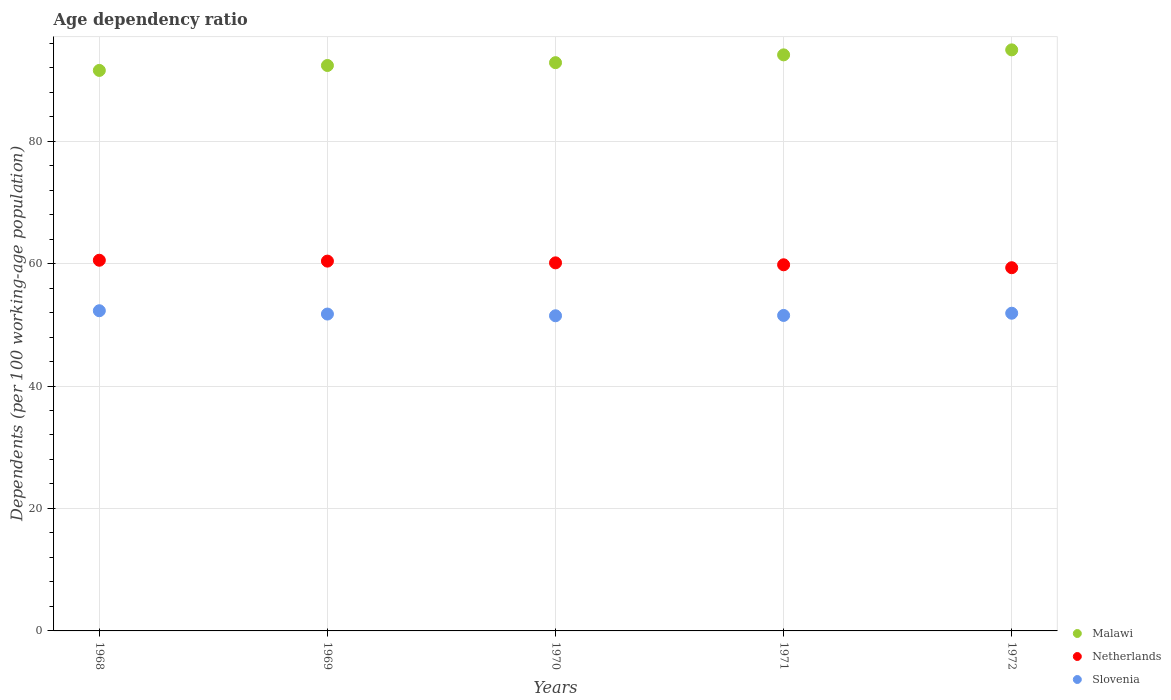What is the age dependency ratio in in Slovenia in 1972?
Offer a terse response. 51.89. Across all years, what is the maximum age dependency ratio in in Slovenia?
Provide a succinct answer. 52.3. Across all years, what is the minimum age dependency ratio in in Malawi?
Ensure brevity in your answer.  91.55. In which year was the age dependency ratio in in Slovenia maximum?
Ensure brevity in your answer.  1968. In which year was the age dependency ratio in in Slovenia minimum?
Keep it short and to the point. 1970. What is the total age dependency ratio in in Slovenia in the graph?
Your response must be concise. 258.94. What is the difference between the age dependency ratio in in Malawi in 1969 and that in 1970?
Ensure brevity in your answer.  -0.46. What is the difference between the age dependency ratio in in Malawi in 1968 and the age dependency ratio in in Slovenia in 1970?
Your answer should be compact. 40.07. What is the average age dependency ratio in in Netherlands per year?
Your answer should be very brief. 60.04. In the year 1969, what is the difference between the age dependency ratio in in Slovenia and age dependency ratio in in Netherlands?
Give a very brief answer. -8.65. What is the ratio of the age dependency ratio in in Malawi in 1969 to that in 1971?
Your answer should be very brief. 0.98. Is the difference between the age dependency ratio in in Slovenia in 1968 and 1971 greater than the difference between the age dependency ratio in in Netherlands in 1968 and 1971?
Offer a very short reply. Yes. What is the difference between the highest and the second highest age dependency ratio in in Malawi?
Your answer should be very brief. 0.82. What is the difference between the highest and the lowest age dependency ratio in in Netherlands?
Give a very brief answer. 1.22. In how many years, is the age dependency ratio in in Netherlands greater than the average age dependency ratio in in Netherlands taken over all years?
Your answer should be very brief. 3. Is the sum of the age dependency ratio in in Netherlands in 1970 and 1972 greater than the maximum age dependency ratio in in Slovenia across all years?
Offer a terse response. Yes. Is the age dependency ratio in in Netherlands strictly greater than the age dependency ratio in in Slovenia over the years?
Your answer should be compact. Yes. Is the age dependency ratio in in Netherlands strictly less than the age dependency ratio in in Malawi over the years?
Your response must be concise. Yes. How many dotlines are there?
Offer a very short reply. 3. How many years are there in the graph?
Your response must be concise. 5. Does the graph contain any zero values?
Your answer should be very brief. No. Where does the legend appear in the graph?
Keep it short and to the point. Bottom right. How are the legend labels stacked?
Provide a short and direct response. Vertical. What is the title of the graph?
Keep it short and to the point. Age dependency ratio. What is the label or title of the Y-axis?
Offer a terse response. Dependents (per 100 working-age population). What is the Dependents (per 100 working-age population) in Malawi in 1968?
Give a very brief answer. 91.55. What is the Dependents (per 100 working-age population) in Netherlands in 1968?
Your answer should be very brief. 60.54. What is the Dependents (per 100 working-age population) in Slovenia in 1968?
Your answer should be compact. 52.3. What is the Dependents (per 100 working-age population) of Malawi in 1969?
Ensure brevity in your answer.  92.35. What is the Dependents (per 100 working-age population) of Netherlands in 1969?
Your answer should be compact. 60.4. What is the Dependents (per 100 working-age population) of Slovenia in 1969?
Your answer should be very brief. 51.75. What is the Dependents (per 100 working-age population) of Malawi in 1970?
Offer a very short reply. 92.81. What is the Dependents (per 100 working-age population) of Netherlands in 1970?
Give a very brief answer. 60.12. What is the Dependents (per 100 working-age population) of Slovenia in 1970?
Give a very brief answer. 51.47. What is the Dependents (per 100 working-age population) in Malawi in 1971?
Ensure brevity in your answer.  94.09. What is the Dependents (per 100 working-age population) in Netherlands in 1971?
Provide a short and direct response. 59.8. What is the Dependents (per 100 working-age population) of Slovenia in 1971?
Make the answer very short. 51.53. What is the Dependents (per 100 working-age population) in Malawi in 1972?
Keep it short and to the point. 94.9. What is the Dependents (per 100 working-age population) in Netherlands in 1972?
Ensure brevity in your answer.  59.32. What is the Dependents (per 100 working-age population) in Slovenia in 1972?
Give a very brief answer. 51.89. Across all years, what is the maximum Dependents (per 100 working-age population) of Malawi?
Give a very brief answer. 94.9. Across all years, what is the maximum Dependents (per 100 working-age population) of Netherlands?
Make the answer very short. 60.54. Across all years, what is the maximum Dependents (per 100 working-age population) of Slovenia?
Your answer should be compact. 52.3. Across all years, what is the minimum Dependents (per 100 working-age population) of Malawi?
Make the answer very short. 91.55. Across all years, what is the minimum Dependents (per 100 working-age population) of Netherlands?
Your answer should be compact. 59.32. Across all years, what is the minimum Dependents (per 100 working-age population) in Slovenia?
Your answer should be compact. 51.47. What is the total Dependents (per 100 working-age population) of Malawi in the graph?
Make the answer very short. 465.7. What is the total Dependents (per 100 working-age population) in Netherlands in the graph?
Ensure brevity in your answer.  300.18. What is the total Dependents (per 100 working-age population) in Slovenia in the graph?
Your answer should be compact. 258.94. What is the difference between the Dependents (per 100 working-age population) of Malawi in 1968 and that in 1969?
Ensure brevity in your answer.  -0.8. What is the difference between the Dependents (per 100 working-age population) in Netherlands in 1968 and that in 1969?
Offer a terse response. 0.14. What is the difference between the Dependents (per 100 working-age population) of Slovenia in 1968 and that in 1969?
Give a very brief answer. 0.54. What is the difference between the Dependents (per 100 working-age population) in Malawi in 1968 and that in 1970?
Your response must be concise. -1.27. What is the difference between the Dependents (per 100 working-age population) in Netherlands in 1968 and that in 1970?
Your answer should be compact. 0.43. What is the difference between the Dependents (per 100 working-age population) in Slovenia in 1968 and that in 1970?
Give a very brief answer. 0.82. What is the difference between the Dependents (per 100 working-age population) of Malawi in 1968 and that in 1971?
Provide a short and direct response. -2.54. What is the difference between the Dependents (per 100 working-age population) of Netherlands in 1968 and that in 1971?
Your answer should be compact. 0.74. What is the difference between the Dependents (per 100 working-age population) in Slovenia in 1968 and that in 1971?
Your answer should be very brief. 0.77. What is the difference between the Dependents (per 100 working-age population) in Malawi in 1968 and that in 1972?
Your answer should be compact. -3.36. What is the difference between the Dependents (per 100 working-age population) in Netherlands in 1968 and that in 1972?
Offer a very short reply. 1.22. What is the difference between the Dependents (per 100 working-age population) in Slovenia in 1968 and that in 1972?
Offer a very short reply. 0.41. What is the difference between the Dependents (per 100 working-age population) in Malawi in 1969 and that in 1970?
Give a very brief answer. -0.46. What is the difference between the Dependents (per 100 working-age population) in Netherlands in 1969 and that in 1970?
Offer a very short reply. 0.28. What is the difference between the Dependents (per 100 working-age population) of Slovenia in 1969 and that in 1970?
Make the answer very short. 0.28. What is the difference between the Dependents (per 100 working-age population) in Malawi in 1969 and that in 1971?
Make the answer very short. -1.74. What is the difference between the Dependents (per 100 working-age population) of Netherlands in 1969 and that in 1971?
Keep it short and to the point. 0.6. What is the difference between the Dependents (per 100 working-age population) in Slovenia in 1969 and that in 1971?
Provide a short and direct response. 0.23. What is the difference between the Dependents (per 100 working-age population) of Malawi in 1969 and that in 1972?
Offer a terse response. -2.55. What is the difference between the Dependents (per 100 working-age population) in Netherlands in 1969 and that in 1972?
Provide a short and direct response. 1.08. What is the difference between the Dependents (per 100 working-age population) of Slovenia in 1969 and that in 1972?
Your response must be concise. -0.13. What is the difference between the Dependents (per 100 working-age population) in Malawi in 1970 and that in 1971?
Your answer should be very brief. -1.27. What is the difference between the Dependents (per 100 working-age population) of Netherlands in 1970 and that in 1971?
Your answer should be compact. 0.32. What is the difference between the Dependents (per 100 working-age population) of Slovenia in 1970 and that in 1971?
Your answer should be compact. -0.05. What is the difference between the Dependents (per 100 working-age population) of Malawi in 1970 and that in 1972?
Offer a terse response. -2.09. What is the difference between the Dependents (per 100 working-age population) of Netherlands in 1970 and that in 1972?
Give a very brief answer. 0.79. What is the difference between the Dependents (per 100 working-age population) of Slovenia in 1970 and that in 1972?
Your response must be concise. -0.41. What is the difference between the Dependents (per 100 working-age population) in Malawi in 1971 and that in 1972?
Provide a short and direct response. -0.82. What is the difference between the Dependents (per 100 working-age population) of Netherlands in 1971 and that in 1972?
Your answer should be very brief. 0.48. What is the difference between the Dependents (per 100 working-age population) of Slovenia in 1971 and that in 1972?
Provide a short and direct response. -0.36. What is the difference between the Dependents (per 100 working-age population) in Malawi in 1968 and the Dependents (per 100 working-age population) in Netherlands in 1969?
Give a very brief answer. 31.15. What is the difference between the Dependents (per 100 working-age population) of Malawi in 1968 and the Dependents (per 100 working-age population) of Slovenia in 1969?
Your response must be concise. 39.79. What is the difference between the Dependents (per 100 working-age population) of Netherlands in 1968 and the Dependents (per 100 working-age population) of Slovenia in 1969?
Make the answer very short. 8.79. What is the difference between the Dependents (per 100 working-age population) of Malawi in 1968 and the Dependents (per 100 working-age population) of Netherlands in 1970?
Your response must be concise. 31.43. What is the difference between the Dependents (per 100 working-age population) in Malawi in 1968 and the Dependents (per 100 working-age population) in Slovenia in 1970?
Keep it short and to the point. 40.07. What is the difference between the Dependents (per 100 working-age population) in Netherlands in 1968 and the Dependents (per 100 working-age population) in Slovenia in 1970?
Your answer should be compact. 9.07. What is the difference between the Dependents (per 100 working-age population) of Malawi in 1968 and the Dependents (per 100 working-age population) of Netherlands in 1971?
Provide a succinct answer. 31.75. What is the difference between the Dependents (per 100 working-age population) of Malawi in 1968 and the Dependents (per 100 working-age population) of Slovenia in 1971?
Give a very brief answer. 40.02. What is the difference between the Dependents (per 100 working-age population) in Netherlands in 1968 and the Dependents (per 100 working-age population) in Slovenia in 1971?
Provide a short and direct response. 9.01. What is the difference between the Dependents (per 100 working-age population) in Malawi in 1968 and the Dependents (per 100 working-age population) in Netherlands in 1972?
Provide a succinct answer. 32.22. What is the difference between the Dependents (per 100 working-age population) of Malawi in 1968 and the Dependents (per 100 working-age population) of Slovenia in 1972?
Your answer should be compact. 39.66. What is the difference between the Dependents (per 100 working-age population) in Netherlands in 1968 and the Dependents (per 100 working-age population) in Slovenia in 1972?
Provide a succinct answer. 8.65. What is the difference between the Dependents (per 100 working-age population) in Malawi in 1969 and the Dependents (per 100 working-age population) in Netherlands in 1970?
Ensure brevity in your answer.  32.24. What is the difference between the Dependents (per 100 working-age population) of Malawi in 1969 and the Dependents (per 100 working-age population) of Slovenia in 1970?
Make the answer very short. 40.88. What is the difference between the Dependents (per 100 working-age population) of Netherlands in 1969 and the Dependents (per 100 working-age population) of Slovenia in 1970?
Keep it short and to the point. 8.93. What is the difference between the Dependents (per 100 working-age population) in Malawi in 1969 and the Dependents (per 100 working-age population) in Netherlands in 1971?
Your answer should be very brief. 32.55. What is the difference between the Dependents (per 100 working-age population) of Malawi in 1969 and the Dependents (per 100 working-age population) of Slovenia in 1971?
Your answer should be compact. 40.82. What is the difference between the Dependents (per 100 working-age population) of Netherlands in 1969 and the Dependents (per 100 working-age population) of Slovenia in 1971?
Make the answer very short. 8.87. What is the difference between the Dependents (per 100 working-age population) in Malawi in 1969 and the Dependents (per 100 working-age population) in Netherlands in 1972?
Your answer should be very brief. 33.03. What is the difference between the Dependents (per 100 working-age population) of Malawi in 1969 and the Dependents (per 100 working-age population) of Slovenia in 1972?
Your answer should be very brief. 40.46. What is the difference between the Dependents (per 100 working-age population) of Netherlands in 1969 and the Dependents (per 100 working-age population) of Slovenia in 1972?
Your answer should be very brief. 8.51. What is the difference between the Dependents (per 100 working-age population) in Malawi in 1970 and the Dependents (per 100 working-age population) in Netherlands in 1971?
Make the answer very short. 33.01. What is the difference between the Dependents (per 100 working-age population) in Malawi in 1970 and the Dependents (per 100 working-age population) in Slovenia in 1971?
Your response must be concise. 41.28. What is the difference between the Dependents (per 100 working-age population) in Netherlands in 1970 and the Dependents (per 100 working-age population) in Slovenia in 1971?
Offer a terse response. 8.59. What is the difference between the Dependents (per 100 working-age population) in Malawi in 1970 and the Dependents (per 100 working-age population) in Netherlands in 1972?
Ensure brevity in your answer.  33.49. What is the difference between the Dependents (per 100 working-age population) of Malawi in 1970 and the Dependents (per 100 working-age population) of Slovenia in 1972?
Ensure brevity in your answer.  40.92. What is the difference between the Dependents (per 100 working-age population) of Netherlands in 1970 and the Dependents (per 100 working-age population) of Slovenia in 1972?
Make the answer very short. 8.23. What is the difference between the Dependents (per 100 working-age population) in Malawi in 1971 and the Dependents (per 100 working-age population) in Netherlands in 1972?
Offer a terse response. 34.77. What is the difference between the Dependents (per 100 working-age population) of Malawi in 1971 and the Dependents (per 100 working-age population) of Slovenia in 1972?
Give a very brief answer. 42.2. What is the difference between the Dependents (per 100 working-age population) in Netherlands in 1971 and the Dependents (per 100 working-age population) in Slovenia in 1972?
Your answer should be very brief. 7.91. What is the average Dependents (per 100 working-age population) in Malawi per year?
Provide a succinct answer. 93.14. What is the average Dependents (per 100 working-age population) in Netherlands per year?
Your response must be concise. 60.04. What is the average Dependents (per 100 working-age population) of Slovenia per year?
Keep it short and to the point. 51.79. In the year 1968, what is the difference between the Dependents (per 100 working-age population) of Malawi and Dependents (per 100 working-age population) of Netherlands?
Your answer should be very brief. 31. In the year 1968, what is the difference between the Dependents (per 100 working-age population) in Malawi and Dependents (per 100 working-age population) in Slovenia?
Keep it short and to the point. 39.25. In the year 1968, what is the difference between the Dependents (per 100 working-age population) of Netherlands and Dependents (per 100 working-age population) of Slovenia?
Your response must be concise. 8.25. In the year 1969, what is the difference between the Dependents (per 100 working-age population) in Malawi and Dependents (per 100 working-age population) in Netherlands?
Give a very brief answer. 31.95. In the year 1969, what is the difference between the Dependents (per 100 working-age population) in Malawi and Dependents (per 100 working-age population) in Slovenia?
Your answer should be very brief. 40.6. In the year 1969, what is the difference between the Dependents (per 100 working-age population) in Netherlands and Dependents (per 100 working-age population) in Slovenia?
Make the answer very short. 8.65. In the year 1970, what is the difference between the Dependents (per 100 working-age population) in Malawi and Dependents (per 100 working-age population) in Netherlands?
Your answer should be very brief. 32.7. In the year 1970, what is the difference between the Dependents (per 100 working-age population) of Malawi and Dependents (per 100 working-age population) of Slovenia?
Offer a very short reply. 41.34. In the year 1970, what is the difference between the Dependents (per 100 working-age population) in Netherlands and Dependents (per 100 working-age population) in Slovenia?
Offer a very short reply. 8.64. In the year 1971, what is the difference between the Dependents (per 100 working-age population) of Malawi and Dependents (per 100 working-age population) of Netherlands?
Make the answer very short. 34.29. In the year 1971, what is the difference between the Dependents (per 100 working-age population) of Malawi and Dependents (per 100 working-age population) of Slovenia?
Your response must be concise. 42.56. In the year 1971, what is the difference between the Dependents (per 100 working-age population) of Netherlands and Dependents (per 100 working-age population) of Slovenia?
Provide a short and direct response. 8.27. In the year 1972, what is the difference between the Dependents (per 100 working-age population) of Malawi and Dependents (per 100 working-age population) of Netherlands?
Ensure brevity in your answer.  35.58. In the year 1972, what is the difference between the Dependents (per 100 working-age population) of Malawi and Dependents (per 100 working-age population) of Slovenia?
Your answer should be very brief. 43.01. In the year 1972, what is the difference between the Dependents (per 100 working-age population) of Netherlands and Dependents (per 100 working-age population) of Slovenia?
Give a very brief answer. 7.43. What is the ratio of the Dependents (per 100 working-age population) in Slovenia in 1968 to that in 1969?
Ensure brevity in your answer.  1.01. What is the ratio of the Dependents (per 100 working-age population) in Malawi in 1968 to that in 1970?
Provide a succinct answer. 0.99. What is the ratio of the Dependents (per 100 working-age population) of Netherlands in 1968 to that in 1970?
Offer a very short reply. 1.01. What is the ratio of the Dependents (per 100 working-age population) of Slovenia in 1968 to that in 1970?
Offer a terse response. 1.02. What is the ratio of the Dependents (per 100 working-age population) in Malawi in 1968 to that in 1971?
Offer a very short reply. 0.97. What is the ratio of the Dependents (per 100 working-age population) of Netherlands in 1968 to that in 1971?
Offer a very short reply. 1.01. What is the ratio of the Dependents (per 100 working-age population) of Slovenia in 1968 to that in 1971?
Give a very brief answer. 1.01. What is the ratio of the Dependents (per 100 working-age population) in Malawi in 1968 to that in 1972?
Offer a terse response. 0.96. What is the ratio of the Dependents (per 100 working-age population) of Netherlands in 1968 to that in 1972?
Your answer should be very brief. 1.02. What is the ratio of the Dependents (per 100 working-age population) of Netherlands in 1969 to that in 1970?
Keep it short and to the point. 1. What is the ratio of the Dependents (per 100 working-age population) in Slovenia in 1969 to that in 1970?
Provide a succinct answer. 1.01. What is the ratio of the Dependents (per 100 working-age population) in Malawi in 1969 to that in 1971?
Provide a succinct answer. 0.98. What is the ratio of the Dependents (per 100 working-age population) of Netherlands in 1969 to that in 1971?
Keep it short and to the point. 1.01. What is the ratio of the Dependents (per 100 working-age population) in Slovenia in 1969 to that in 1971?
Your answer should be very brief. 1. What is the ratio of the Dependents (per 100 working-age population) of Malawi in 1969 to that in 1972?
Provide a short and direct response. 0.97. What is the ratio of the Dependents (per 100 working-age population) in Netherlands in 1969 to that in 1972?
Your answer should be very brief. 1.02. What is the ratio of the Dependents (per 100 working-age population) of Malawi in 1970 to that in 1971?
Your answer should be compact. 0.99. What is the ratio of the Dependents (per 100 working-age population) of Netherlands in 1970 to that in 1971?
Provide a short and direct response. 1.01. What is the ratio of the Dependents (per 100 working-age population) of Slovenia in 1970 to that in 1971?
Offer a terse response. 1. What is the ratio of the Dependents (per 100 working-age population) of Malawi in 1970 to that in 1972?
Ensure brevity in your answer.  0.98. What is the ratio of the Dependents (per 100 working-age population) in Netherlands in 1970 to that in 1972?
Keep it short and to the point. 1.01. What is the ratio of the Dependents (per 100 working-age population) of Netherlands in 1971 to that in 1972?
Keep it short and to the point. 1.01. What is the ratio of the Dependents (per 100 working-age population) of Slovenia in 1971 to that in 1972?
Your response must be concise. 0.99. What is the difference between the highest and the second highest Dependents (per 100 working-age population) of Malawi?
Provide a short and direct response. 0.82. What is the difference between the highest and the second highest Dependents (per 100 working-age population) in Netherlands?
Ensure brevity in your answer.  0.14. What is the difference between the highest and the second highest Dependents (per 100 working-age population) of Slovenia?
Keep it short and to the point. 0.41. What is the difference between the highest and the lowest Dependents (per 100 working-age population) in Malawi?
Offer a terse response. 3.36. What is the difference between the highest and the lowest Dependents (per 100 working-age population) in Netherlands?
Give a very brief answer. 1.22. What is the difference between the highest and the lowest Dependents (per 100 working-age population) in Slovenia?
Ensure brevity in your answer.  0.82. 